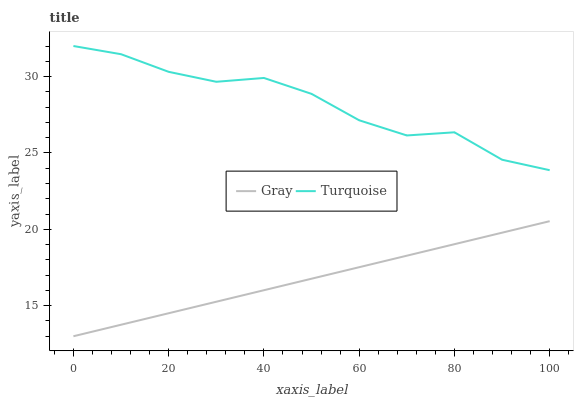Does Gray have the minimum area under the curve?
Answer yes or no. Yes. Does Turquoise have the maximum area under the curve?
Answer yes or no. Yes. Does Turquoise have the minimum area under the curve?
Answer yes or no. No. Is Gray the smoothest?
Answer yes or no. Yes. Is Turquoise the roughest?
Answer yes or no. Yes. Is Turquoise the smoothest?
Answer yes or no. No. Does Turquoise have the lowest value?
Answer yes or no. No. Is Gray less than Turquoise?
Answer yes or no. Yes. Is Turquoise greater than Gray?
Answer yes or no. Yes. Does Gray intersect Turquoise?
Answer yes or no. No. 